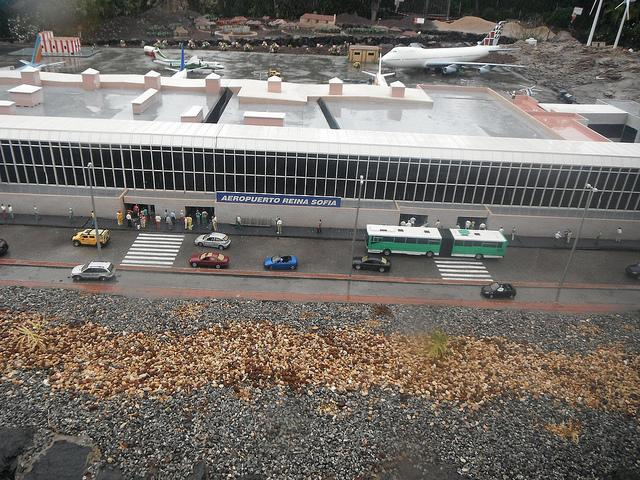What country is this location? Please explain your reasoning. spain. The country would be spain. 